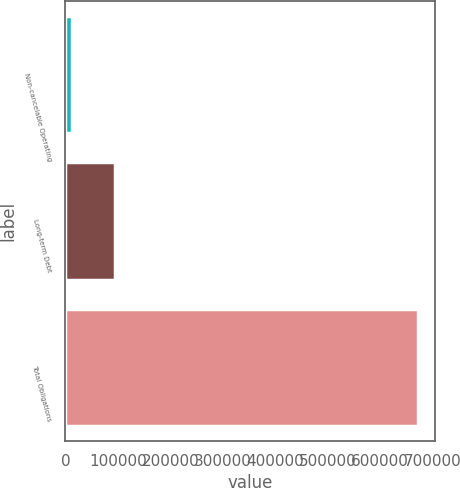Convert chart to OTSL. <chart><loc_0><loc_0><loc_500><loc_500><bar_chart><fcel>Non-cancelable Operating<fcel>Long-term Debt<fcel>Total Obligations<nl><fcel>12771<fcel>93651<fcel>671722<nl></chart> 